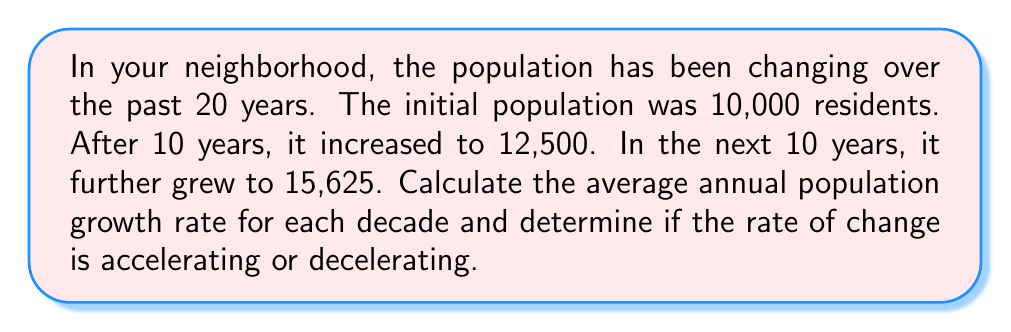Show me your answer to this math problem. To solve this problem, we'll use the compound annual growth rate (CAGR) formula:

$$ CAGR = \left(\frac{Ending Value}{Beginning Value}\right)^{\frac{1}{n}} - 1 $$

Where $n$ is the number of years.

For the first decade (0-10 years):
$$ CAGR_1 = \left(\frac{12,500}{10,000}\right)^{\frac{1}{10}} - 1 $$
$$ CAGR_1 = (1.25)^{0.1} - 1 $$
$$ CAGR_1 = 1.0225 - 1 = 0.0225 = 2.25\% $$

For the second decade (10-20 years):
$$ CAGR_2 = \left(\frac{15,625}{12,500}\right)^{\frac{1}{10}} - 1 $$
$$ CAGR_2 = (1.25)^{0.1} - 1 $$
$$ CAGR_2 = 1.0225 - 1 = 0.0225 = 2.25\% $$

To determine if the rate of change is accelerating or decelerating, we compare the two growth rates:

$CAGR_1 = CAGR_2 = 2.25\%$

Since the growth rates are equal, the population growth is neither accelerating nor decelerating. It is maintaining a constant rate of change.
Answer: The average annual population growth rate for both decades is 2.25%. The rate of change is constant, neither accelerating nor decelerating. 